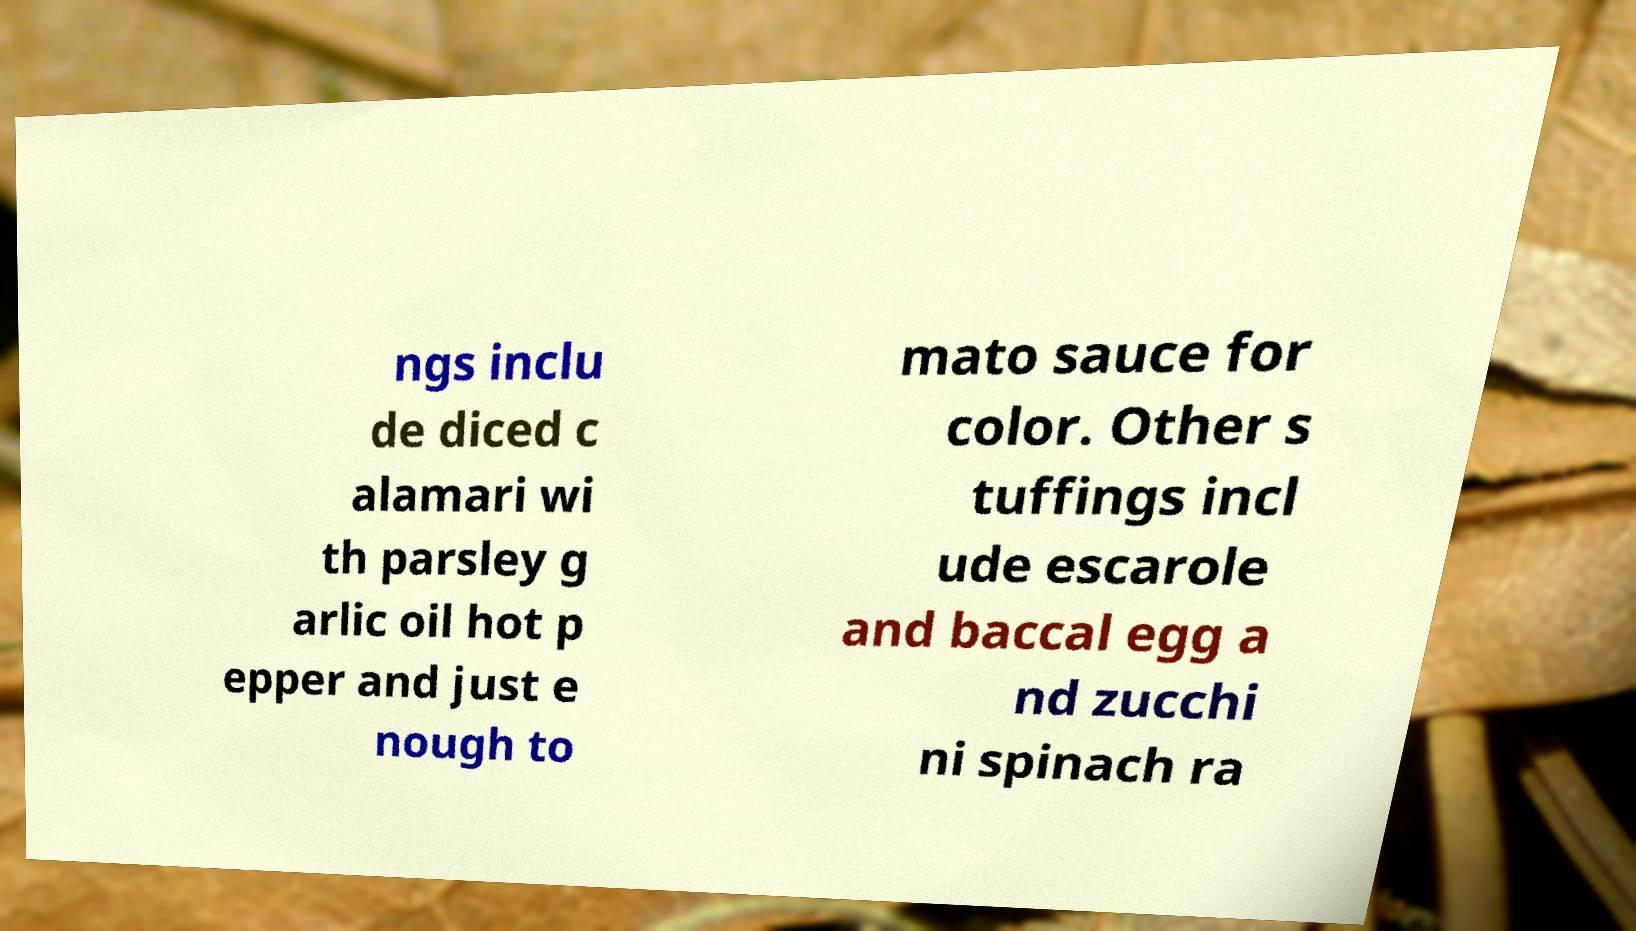Can you accurately transcribe the text from the provided image for me? ngs inclu de diced c alamari wi th parsley g arlic oil hot p epper and just e nough to mato sauce for color. Other s tuffings incl ude escarole and baccal egg a nd zucchi ni spinach ra 